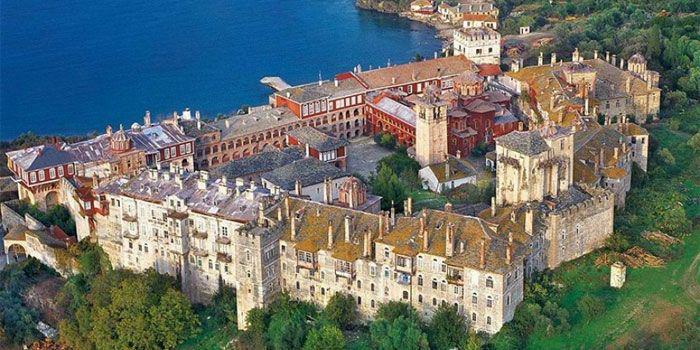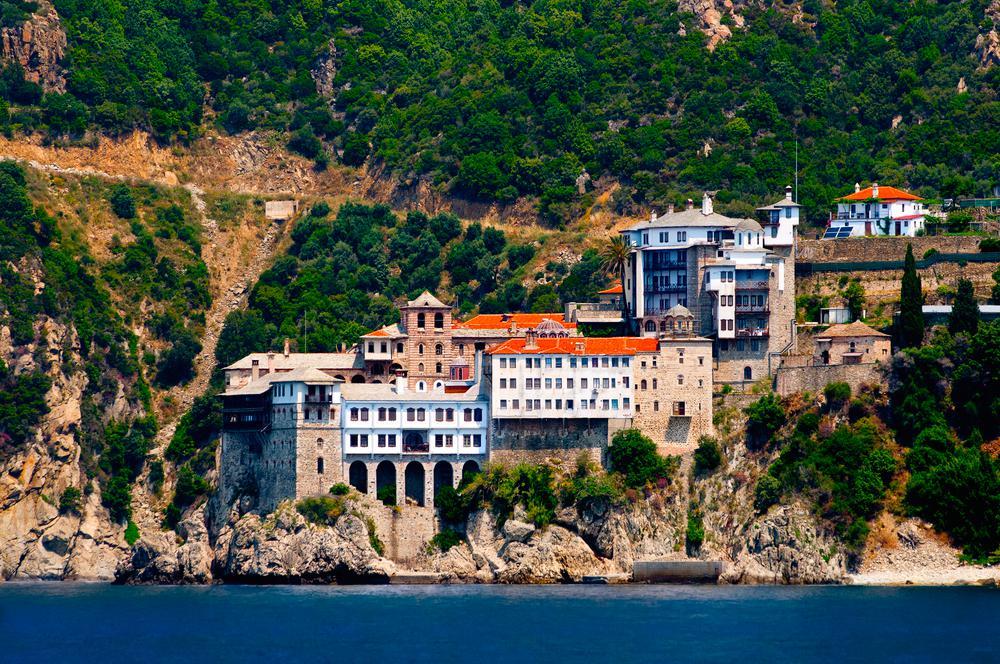The first image is the image on the left, the second image is the image on the right. Evaluate the accuracy of this statement regarding the images: "There are hazy clouds in the image on the right.". Is it true? Answer yes or no. No. 